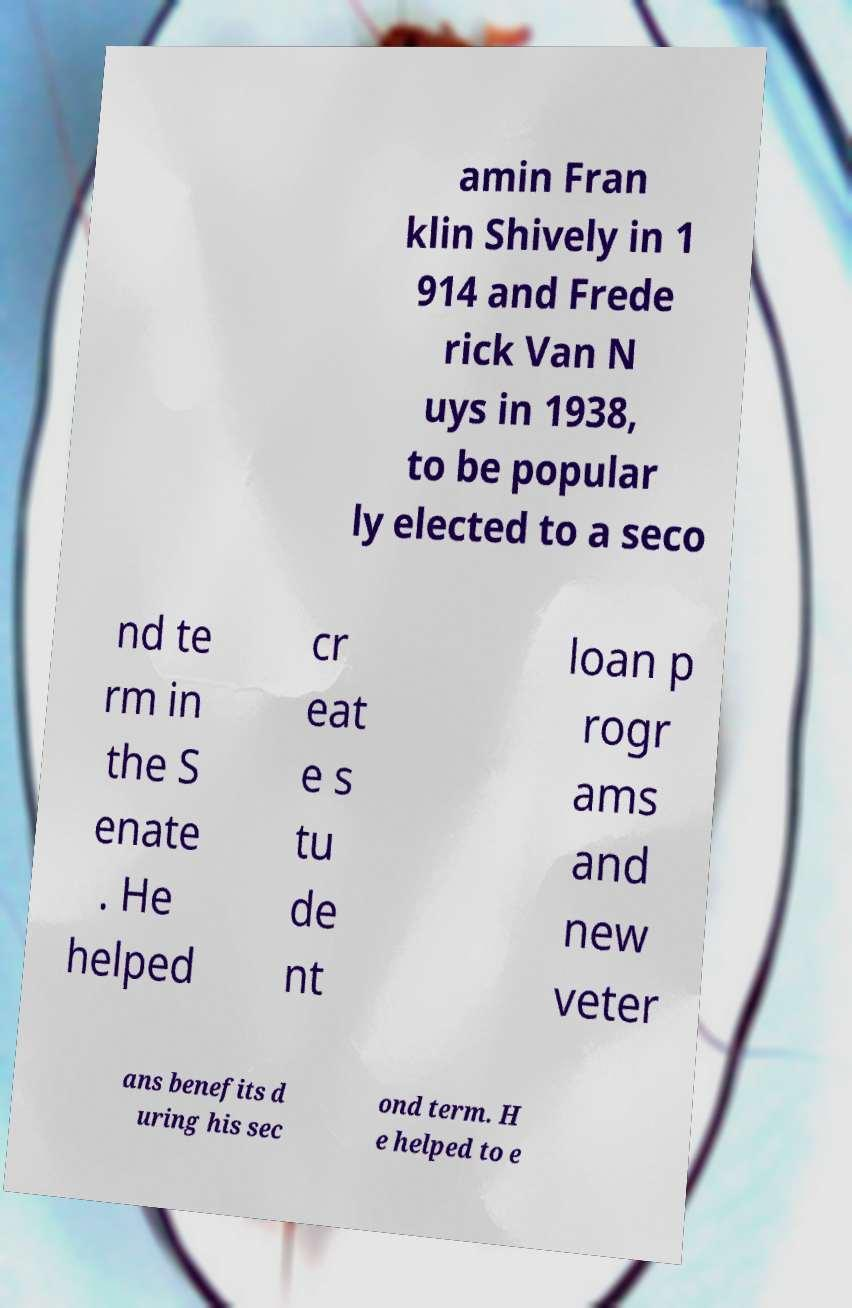Can you accurately transcribe the text from the provided image for me? amin Fran klin Shively in 1 914 and Frede rick Van N uys in 1938, to be popular ly elected to a seco nd te rm in the S enate . He helped cr eat e s tu de nt loan p rogr ams and new veter ans benefits d uring his sec ond term. H e helped to e 